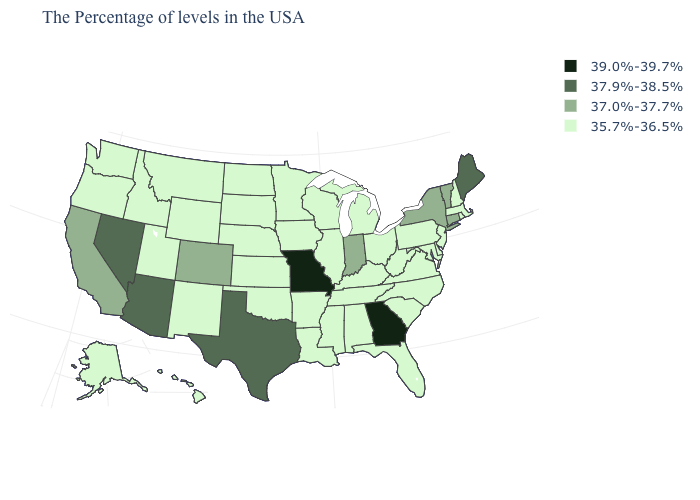What is the value of New Hampshire?
Write a very short answer. 35.7%-36.5%. Among the states that border Michigan , which have the lowest value?
Answer briefly. Ohio, Wisconsin. Name the states that have a value in the range 37.0%-37.7%?
Write a very short answer. Vermont, Connecticut, New York, Indiana, Colorado, California. Name the states that have a value in the range 35.7%-36.5%?
Write a very short answer. Massachusetts, Rhode Island, New Hampshire, New Jersey, Delaware, Maryland, Pennsylvania, Virginia, North Carolina, South Carolina, West Virginia, Ohio, Florida, Michigan, Kentucky, Alabama, Tennessee, Wisconsin, Illinois, Mississippi, Louisiana, Arkansas, Minnesota, Iowa, Kansas, Nebraska, Oklahoma, South Dakota, North Dakota, Wyoming, New Mexico, Utah, Montana, Idaho, Washington, Oregon, Alaska, Hawaii. Does New Hampshire have the lowest value in the USA?
Give a very brief answer. Yes. What is the value of California?
Short answer required. 37.0%-37.7%. Does the first symbol in the legend represent the smallest category?
Write a very short answer. No. Does Kansas have the same value as Montana?
Quick response, please. Yes. Does Arkansas have the same value as Rhode Island?
Quick response, please. Yes. Name the states that have a value in the range 35.7%-36.5%?
Concise answer only. Massachusetts, Rhode Island, New Hampshire, New Jersey, Delaware, Maryland, Pennsylvania, Virginia, North Carolina, South Carolina, West Virginia, Ohio, Florida, Michigan, Kentucky, Alabama, Tennessee, Wisconsin, Illinois, Mississippi, Louisiana, Arkansas, Minnesota, Iowa, Kansas, Nebraska, Oklahoma, South Dakota, North Dakota, Wyoming, New Mexico, Utah, Montana, Idaho, Washington, Oregon, Alaska, Hawaii. What is the highest value in the USA?
Answer briefly. 39.0%-39.7%. Name the states that have a value in the range 35.7%-36.5%?
Keep it brief. Massachusetts, Rhode Island, New Hampshire, New Jersey, Delaware, Maryland, Pennsylvania, Virginia, North Carolina, South Carolina, West Virginia, Ohio, Florida, Michigan, Kentucky, Alabama, Tennessee, Wisconsin, Illinois, Mississippi, Louisiana, Arkansas, Minnesota, Iowa, Kansas, Nebraska, Oklahoma, South Dakota, North Dakota, Wyoming, New Mexico, Utah, Montana, Idaho, Washington, Oregon, Alaska, Hawaii. What is the value of Wisconsin?
Short answer required. 35.7%-36.5%. Does Nevada have the highest value in the West?
Concise answer only. Yes. 